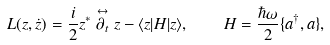<formula> <loc_0><loc_0><loc_500><loc_500>L ( z , \dot { z } ) = \frac { i } { 2 } z ^ { * } \stackrel { \leftrightarrow } { \partial _ { t } } z - \langle z | H | z \rangle , \quad H = \frac { \hbar { \omega } } { 2 } \{ a ^ { \dag } , a \} ,</formula> 